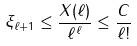<formula> <loc_0><loc_0><loc_500><loc_500>\xi _ { \ell + 1 } \leq \frac { X ( \ell ) } { \ell ^ { \ell } } \leq \frac { C } { \ell ! }</formula> 